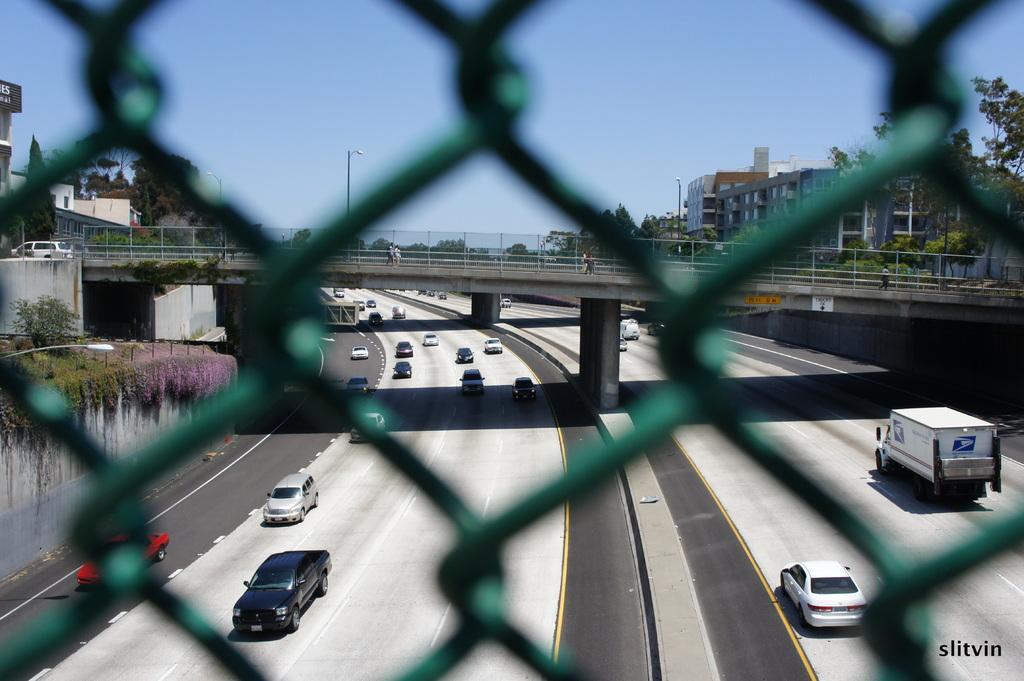Describe this image in one or two sentences. In this picture there is a net in the foreground area of the image and there are buildings, cars, poles, trees, and a bridge in the image. 